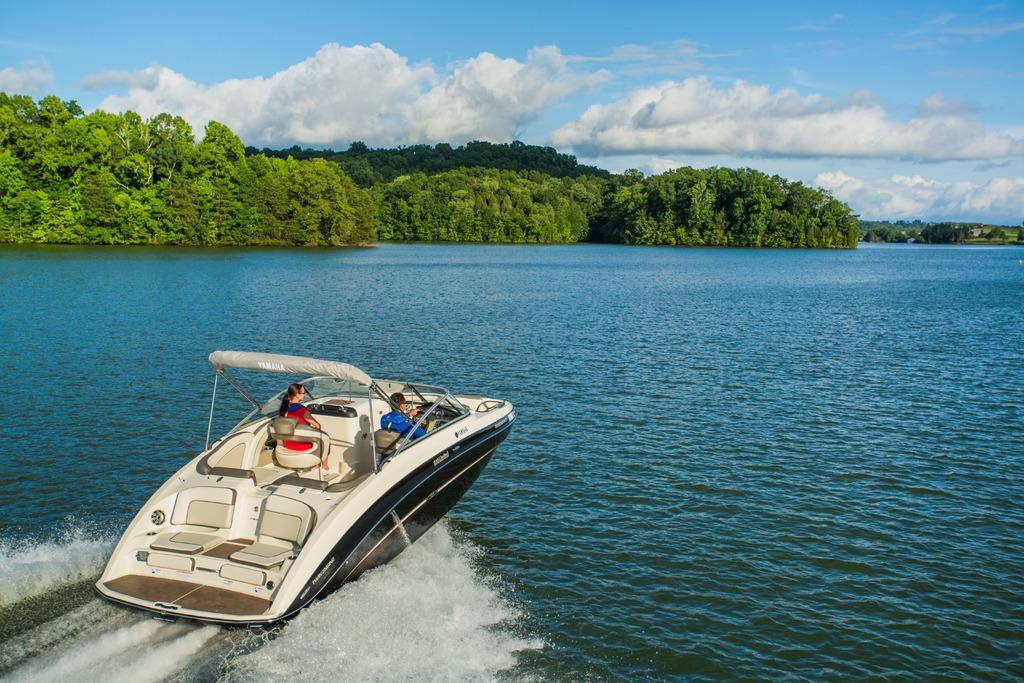Describe this image in one or two sentences. In this image there are two people boating on the water beside that there are trees and also there is a land with grass. 